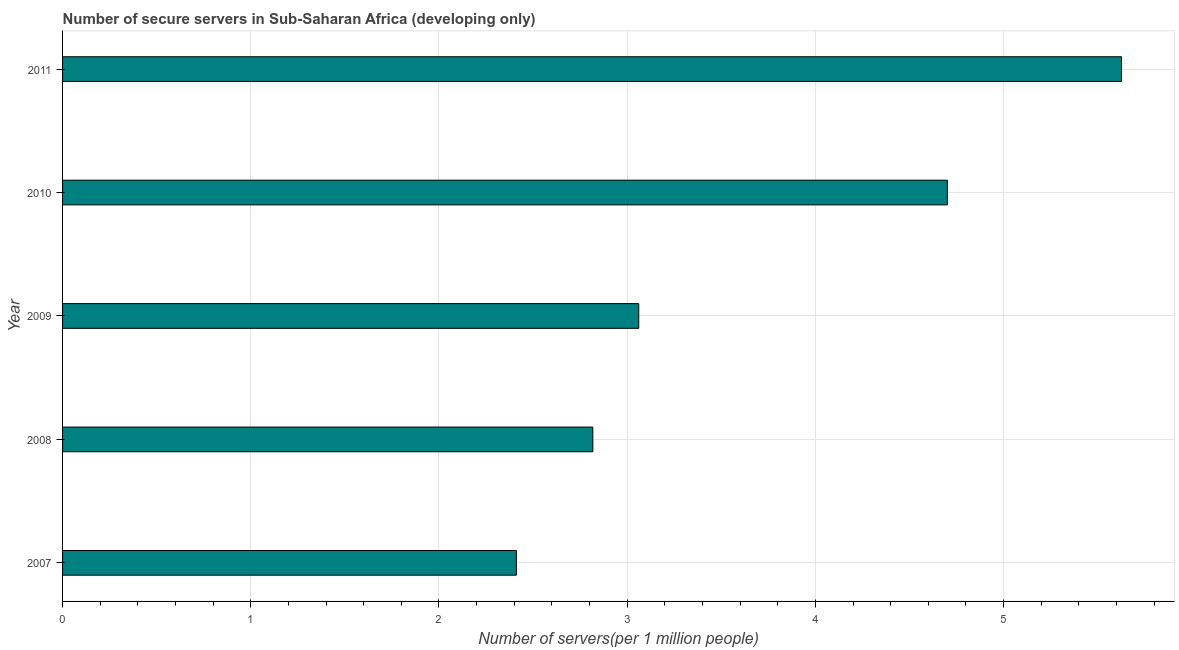What is the title of the graph?
Your answer should be very brief. Number of secure servers in Sub-Saharan Africa (developing only). What is the label or title of the X-axis?
Give a very brief answer. Number of servers(per 1 million people). What is the label or title of the Y-axis?
Make the answer very short. Year. What is the number of secure internet servers in 2010?
Your answer should be very brief. 4.7. Across all years, what is the maximum number of secure internet servers?
Your response must be concise. 5.63. Across all years, what is the minimum number of secure internet servers?
Your answer should be compact. 2.41. In which year was the number of secure internet servers maximum?
Provide a succinct answer. 2011. What is the sum of the number of secure internet servers?
Provide a short and direct response. 18.62. What is the difference between the number of secure internet servers in 2008 and 2009?
Your answer should be very brief. -0.24. What is the average number of secure internet servers per year?
Your answer should be very brief. 3.72. What is the median number of secure internet servers?
Offer a terse response. 3.06. In how many years, is the number of secure internet servers greater than 2.4 ?
Offer a very short reply. 5. What is the ratio of the number of secure internet servers in 2007 to that in 2010?
Offer a terse response. 0.51. Is the number of secure internet servers in 2008 less than that in 2011?
Keep it short and to the point. Yes. What is the difference between the highest and the second highest number of secure internet servers?
Give a very brief answer. 0.93. What is the difference between the highest and the lowest number of secure internet servers?
Ensure brevity in your answer.  3.22. How many years are there in the graph?
Your response must be concise. 5. What is the Number of servers(per 1 million people) of 2007?
Your response must be concise. 2.41. What is the Number of servers(per 1 million people) of 2008?
Provide a short and direct response. 2.82. What is the Number of servers(per 1 million people) in 2009?
Ensure brevity in your answer.  3.06. What is the Number of servers(per 1 million people) of 2010?
Make the answer very short. 4.7. What is the Number of servers(per 1 million people) of 2011?
Your answer should be very brief. 5.63. What is the difference between the Number of servers(per 1 million people) in 2007 and 2008?
Your answer should be compact. -0.41. What is the difference between the Number of servers(per 1 million people) in 2007 and 2009?
Provide a short and direct response. -0.65. What is the difference between the Number of servers(per 1 million people) in 2007 and 2010?
Provide a short and direct response. -2.29. What is the difference between the Number of servers(per 1 million people) in 2007 and 2011?
Offer a very short reply. -3.22. What is the difference between the Number of servers(per 1 million people) in 2008 and 2009?
Your response must be concise. -0.24. What is the difference between the Number of servers(per 1 million people) in 2008 and 2010?
Your answer should be compact. -1.88. What is the difference between the Number of servers(per 1 million people) in 2008 and 2011?
Your answer should be very brief. -2.81. What is the difference between the Number of servers(per 1 million people) in 2009 and 2010?
Provide a succinct answer. -1.64. What is the difference between the Number of servers(per 1 million people) in 2009 and 2011?
Offer a very short reply. -2.57. What is the difference between the Number of servers(per 1 million people) in 2010 and 2011?
Offer a terse response. -0.93. What is the ratio of the Number of servers(per 1 million people) in 2007 to that in 2008?
Provide a short and direct response. 0.86. What is the ratio of the Number of servers(per 1 million people) in 2007 to that in 2009?
Your answer should be very brief. 0.79. What is the ratio of the Number of servers(per 1 million people) in 2007 to that in 2010?
Your response must be concise. 0.51. What is the ratio of the Number of servers(per 1 million people) in 2007 to that in 2011?
Your answer should be compact. 0.43. What is the ratio of the Number of servers(per 1 million people) in 2008 to that in 2009?
Your answer should be compact. 0.92. What is the ratio of the Number of servers(per 1 million people) in 2008 to that in 2010?
Provide a short and direct response. 0.6. What is the ratio of the Number of servers(per 1 million people) in 2008 to that in 2011?
Your response must be concise. 0.5. What is the ratio of the Number of servers(per 1 million people) in 2009 to that in 2010?
Your answer should be very brief. 0.65. What is the ratio of the Number of servers(per 1 million people) in 2009 to that in 2011?
Provide a short and direct response. 0.54. What is the ratio of the Number of servers(per 1 million people) in 2010 to that in 2011?
Provide a short and direct response. 0.84. 